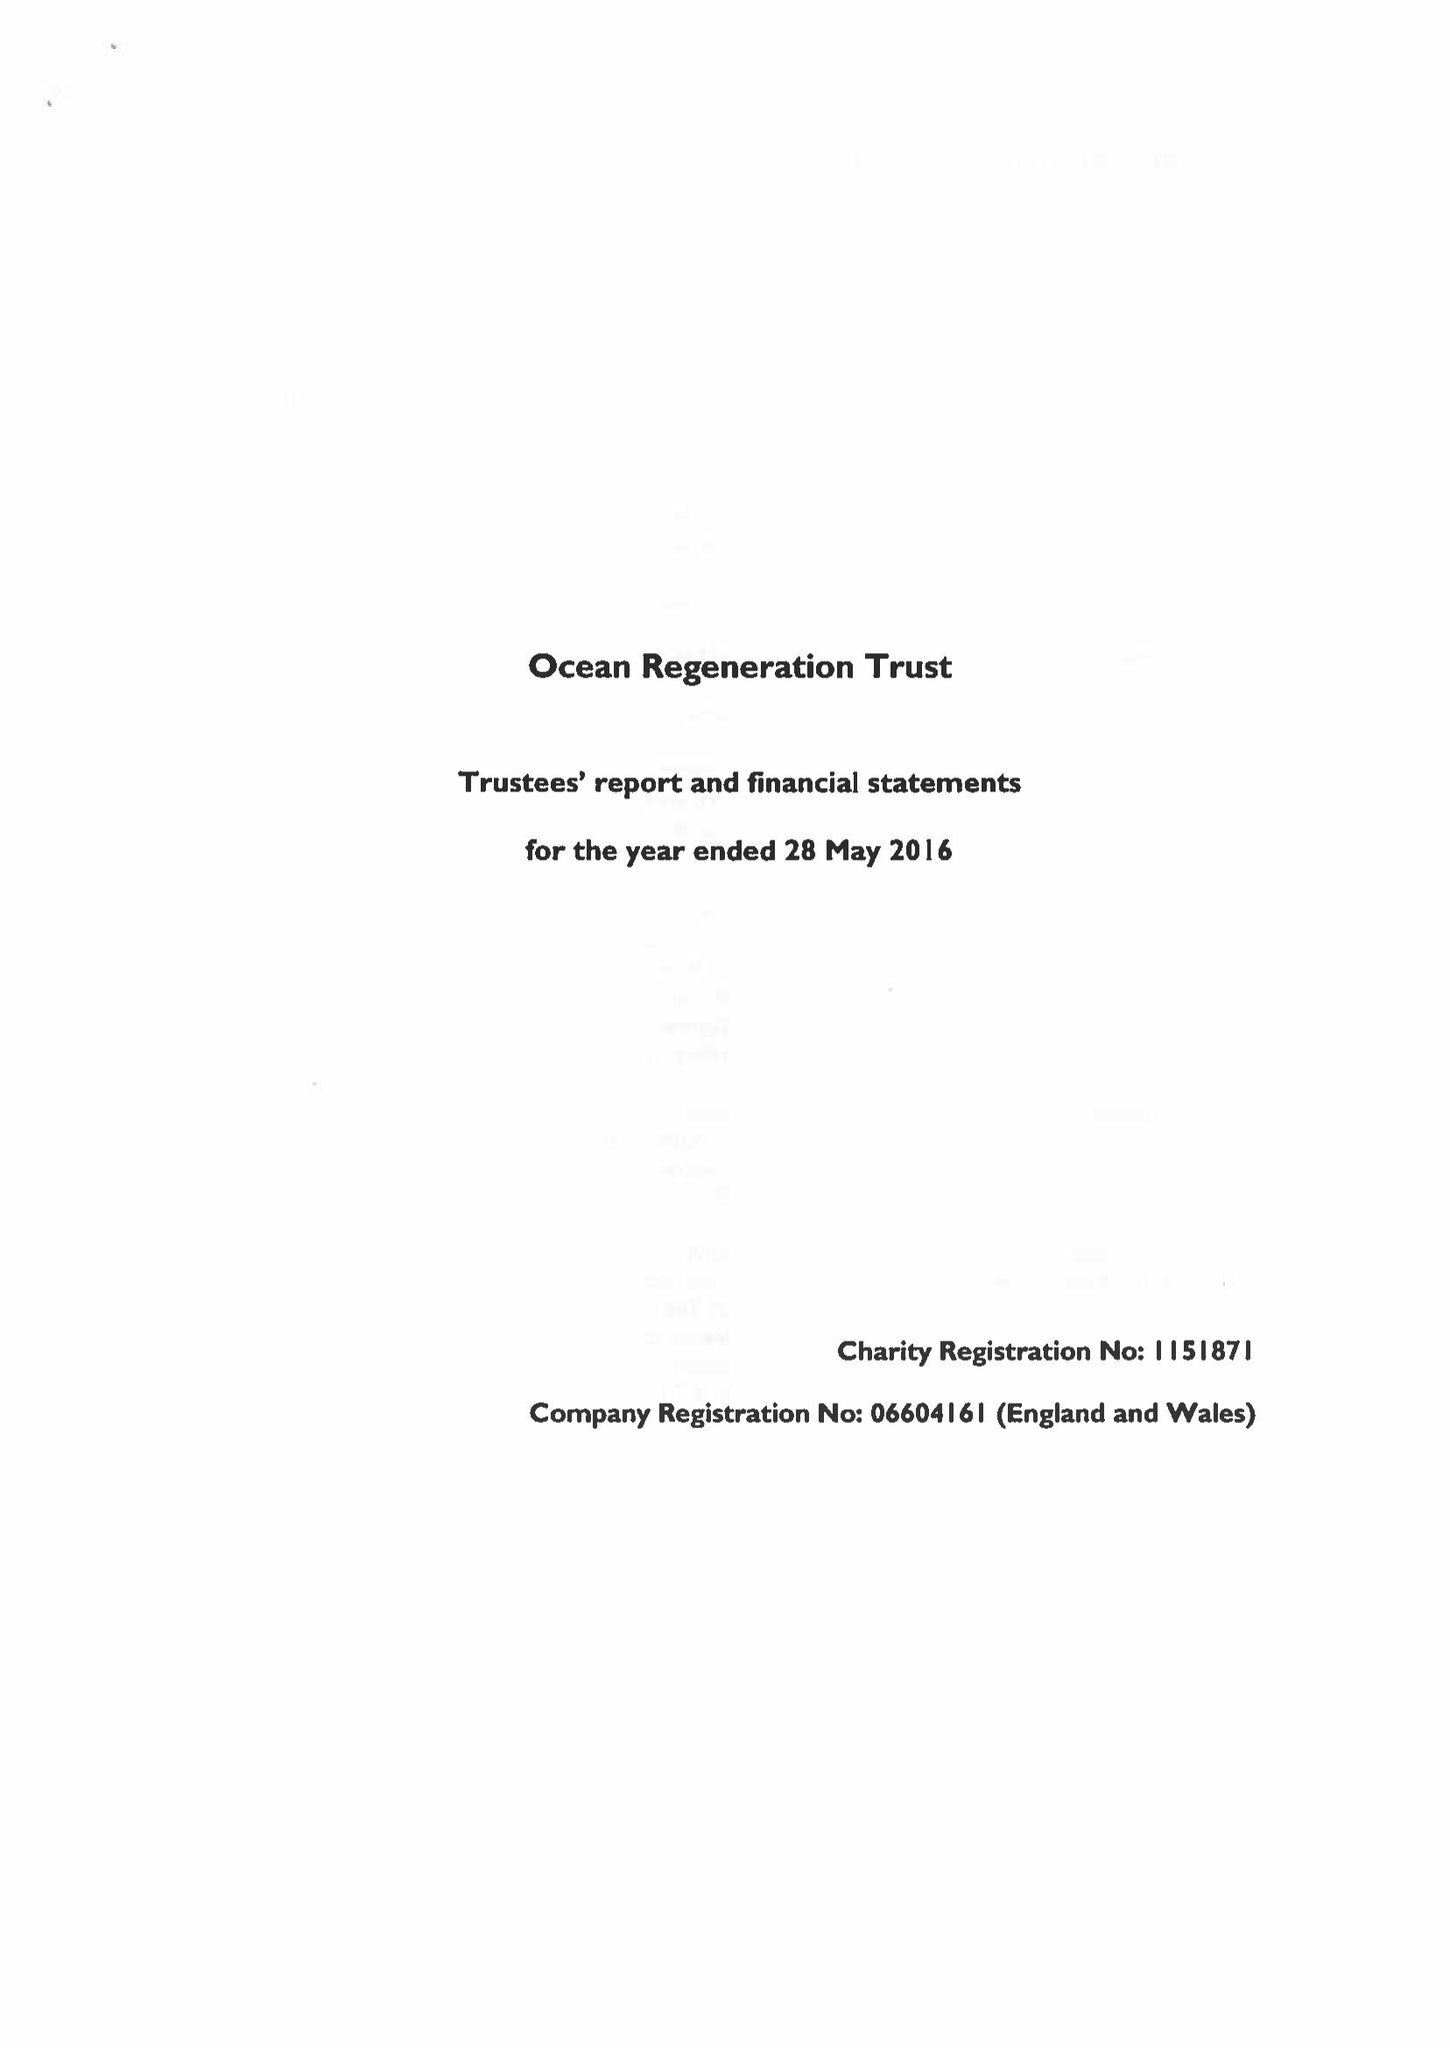What is the value for the spending_annually_in_british_pounds?
Answer the question using a single word or phrase. 213904.00 